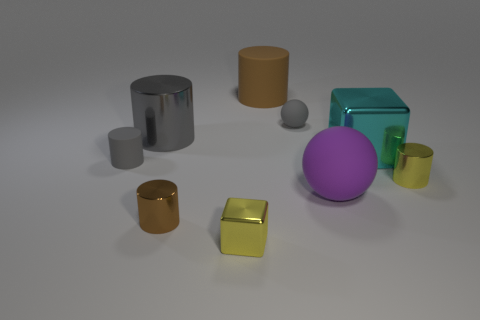Which object in the image appears to have the smoothest surface? The purple sphere seems to have the smoothest surface, reflecting light evenly and showing no visible texture or imperfections. 